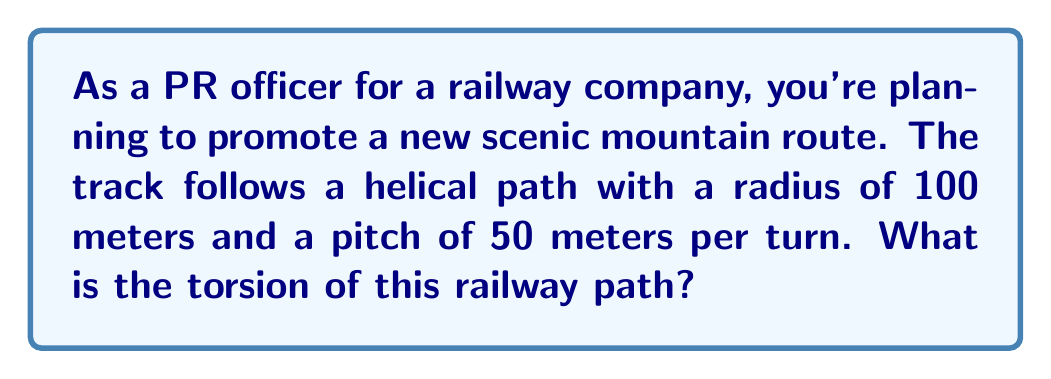Can you answer this question? Let's approach this step-by-step:

1) A helical path can be described parametrically as:
   $$\mathbf{r}(t) = (R\cos(t), R\sin(t), ct)$$
   where $R$ is the radius and $c$ is related to the pitch.

2) In our case, $R = 100$ meters and the pitch is 50 meters per turn. Since one turn corresponds to $2\pi$ in the parameter $t$, we have:
   $$c = \frac{50}{2\pi} = \frac{25}{\pi}$$

3) The torsion of a curve is given by:
   $$\tau = \frac{(\mathbf{r}'(t) \times \mathbf{r}''(t)) \cdot \mathbf{r}'''(t)}{|\mathbf{r}'(t) \times \mathbf{r}''(t)|^2}$$

4) Let's calculate the derivatives:
   $$\mathbf{r}'(t) = (-R\sin(t), R\cos(t), c)$$
   $$\mathbf{r}''(t) = (-R\cos(t), -R\sin(t), 0)$$
   $$\mathbf{r}'''(t) = (R\sin(t), -R\cos(t), 0)$$

5) Now, let's calculate $\mathbf{r}'(t) \times \mathbf{r}''(t)$:
   $$\mathbf{r}'(t) \times \mathbf{r}''(t) = (Rc\sin(t), -Rc\cos(t), R^2)$$

6) The dot product $(\mathbf{r}'(t) \times \mathbf{r}''(t)) \cdot \mathbf{r}'''(t)$:
   $$Rc\sin(t)R\sin(t) + Rc\cos(t)R\cos(t) + 0 = R^2c$$

7) The magnitude $|\mathbf{r}'(t) \times \mathbf{r}''(t)|^2$:
   $$R^2c^2\sin^2(t) + R^2c^2\cos^2(t) + R^4 = R^2(c^2 + R^2)$$

8) Therefore, the torsion is:
   $$\tau = \frac{R^2c}{R^2(c^2 + R^2)} = \frac{c}{c^2 + R^2}$$

9) Substituting the values:
   $$\tau = \frac{25/\pi}{(25/\pi)^2 + 100^2} = \frac{25\pi}{625 + 10000\pi^2} \approx 0.0025 \text{ m}^{-1}$$
Answer: $\frac{25\pi}{625 + 10000\pi^2} \approx 0.0025 \text{ m}^{-1}$ 